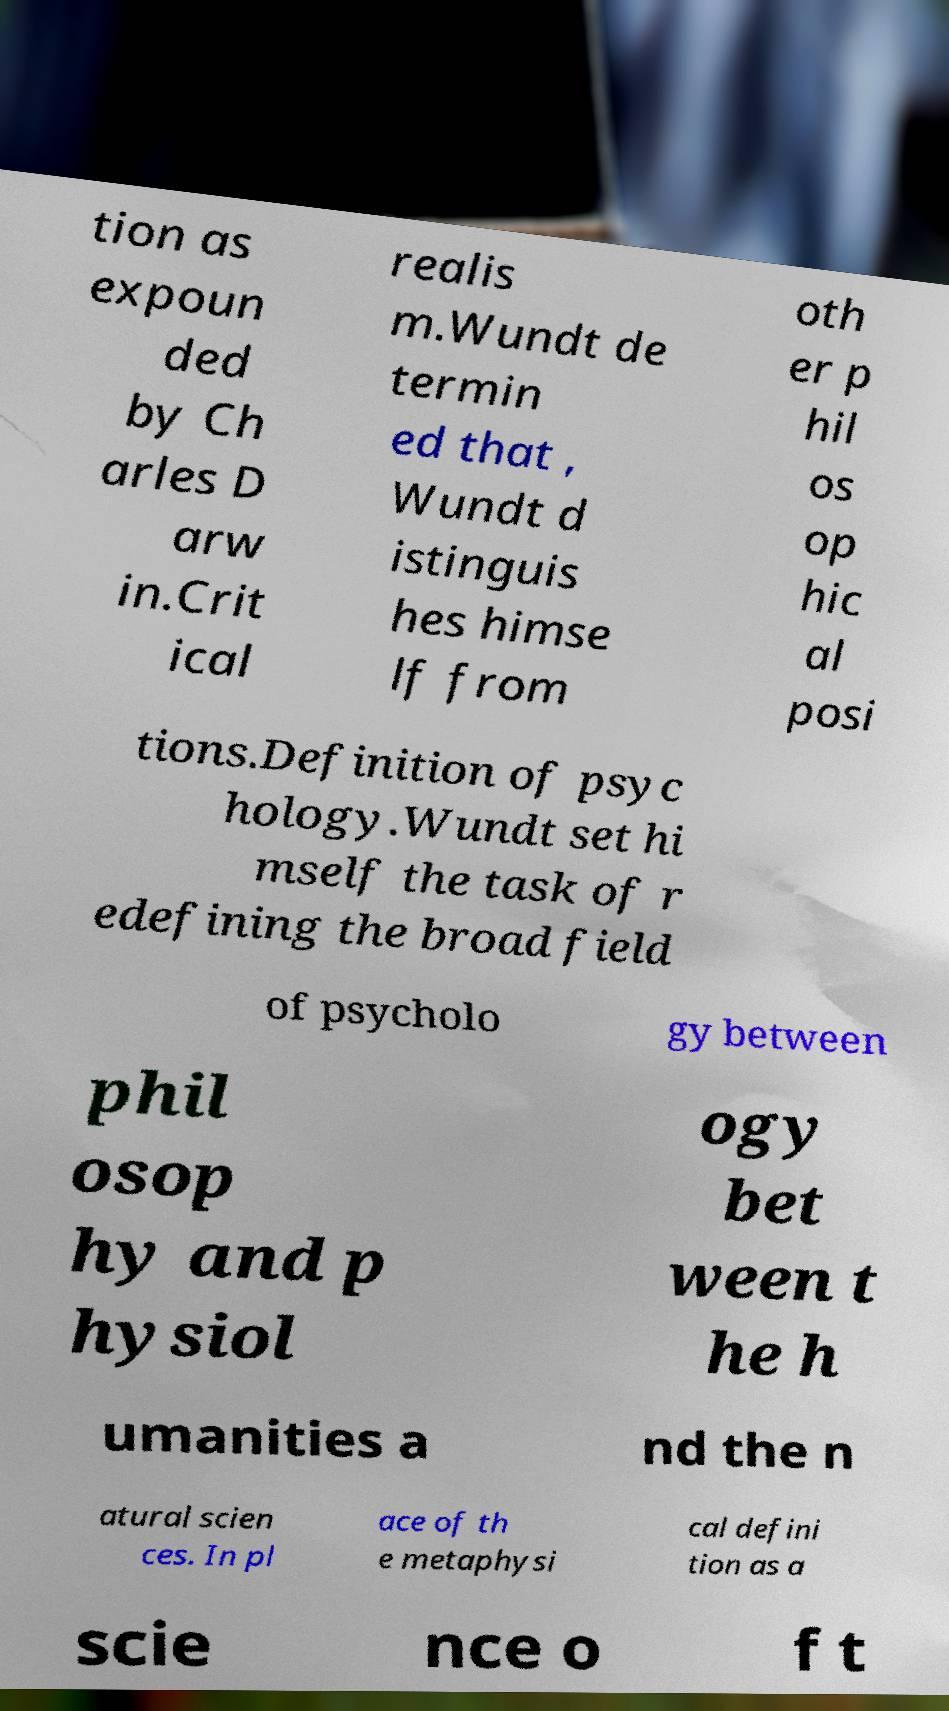Could you extract and type out the text from this image? tion as expoun ded by Ch arles D arw in.Crit ical realis m.Wundt de termin ed that , Wundt d istinguis hes himse lf from oth er p hil os op hic al posi tions.Definition of psyc hology.Wundt set hi mself the task of r edefining the broad field of psycholo gy between phil osop hy and p hysiol ogy bet ween t he h umanities a nd the n atural scien ces. In pl ace of th e metaphysi cal defini tion as a scie nce o f t 